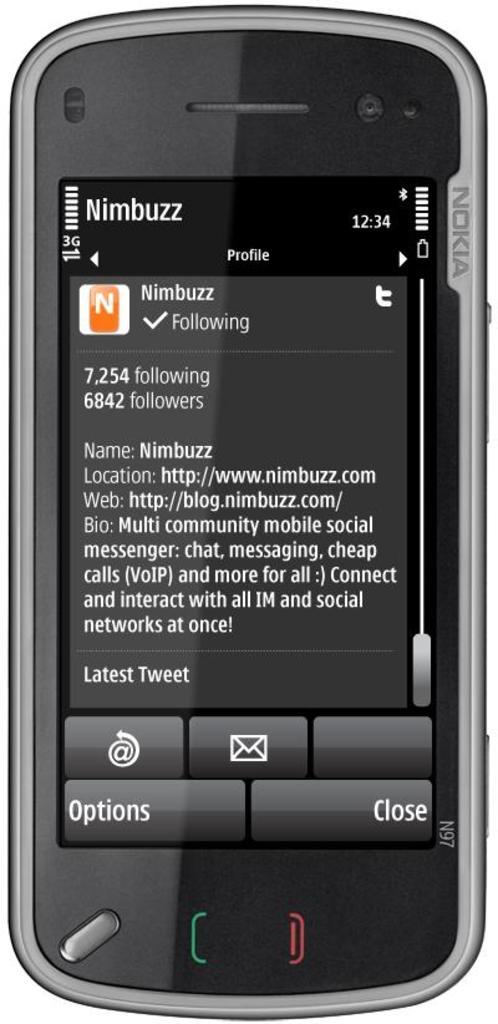<image>
Offer a succinct explanation of the picture presented. a phone that has the number of followers on a text 